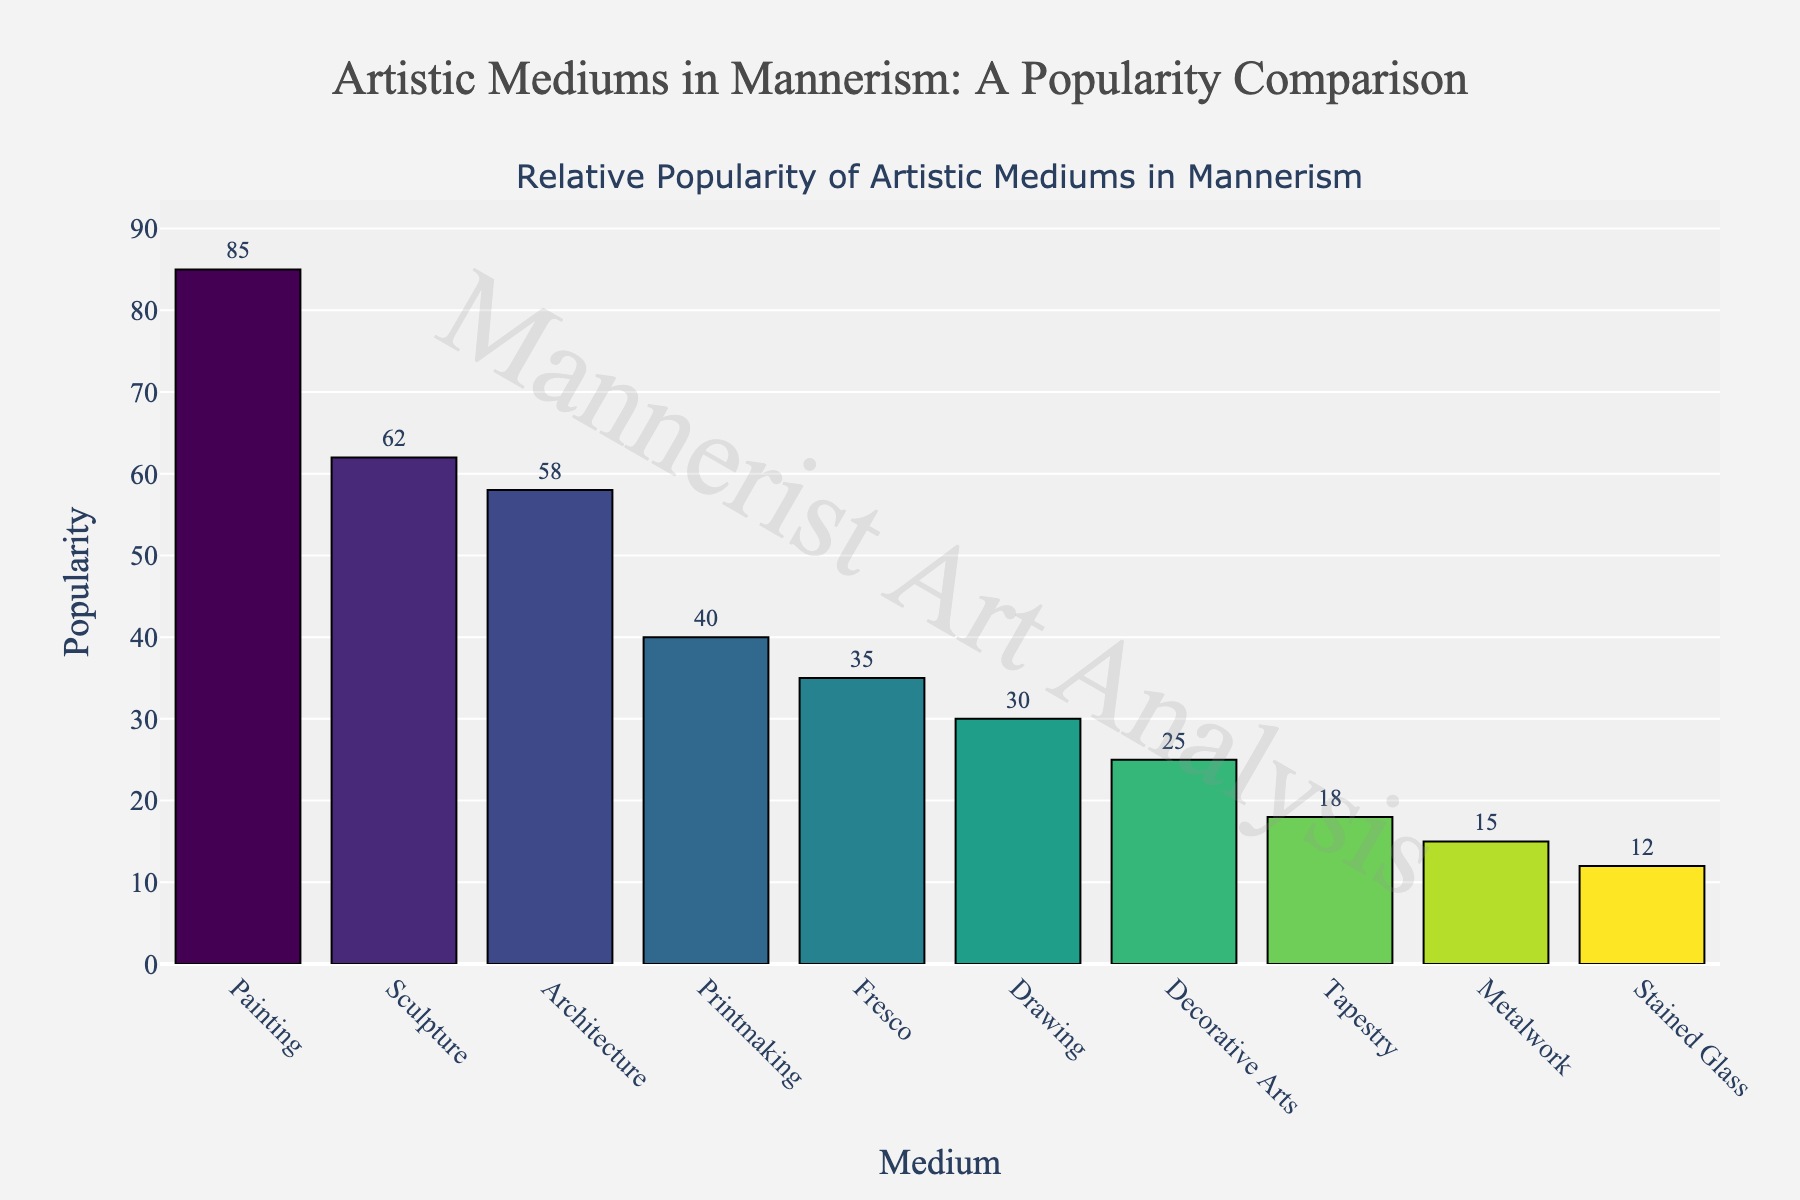Which medium has the highest popularity? We can observe that painting has the tallest bar on the plot.
Answer: Painting What is the combined popularity of the top two mediums? The top two mediums by height of their bars are Painting (85) and Sculpture (62). Their combined popularity is 85 + 62.
Answer: 147 How much more popular is painting than architecture? Painting has a popularity of 85, whereas architecture has 58. The difference is 85 - 58.
Answer: 27 Which medium has the lowest popularity? The smallest bar, indicating the lowest popularity, belongs to Stained Glass with a popularity of 12.
Answer: Stained Glass What is the average popularity of the three least popular mediums? Adding the popularity values of the three smallest bars: Tapestry (18), Metalwork (15), and Stained Glass (12) gives 18 + 15 + 12 = 45. Dividing by 3 gives the average.
Answer: 15 By how much does fresco's popularity exceed that of drawing? Fresco has a popularity of 35, Drawing has a popularity of 30. The difference is 35 - 30.
Answer: 5 Which is more popular, printmaking or decorative arts? Looking at the bars, Printmaking has a value of 40, while Decorative Arts has 25. Printmaking is more popular.
Answer: Printmaking What is the percentage increase in popularity from stained glass to decorative arts? Stained Glass has a popularity of 12, and Decorative Arts has 25. The increase is 25 - 12 = 13. The percentage increase is (13 / 12) × 100.
Answer: Approximately 108.33% How does the popularity of sculpture compare to that of fresco and drawing combined? Sculpture has a popularity of 62. Fresco and Drawing combined have a popularity of 35 + 30 = 65. 62 is less than 65.
Answer: Less What is the range of popularity values in the chart? The highest value is Painting with 85, and the lowest is Stained Glass with 12. The range is 85 - 12.
Answer: 73 